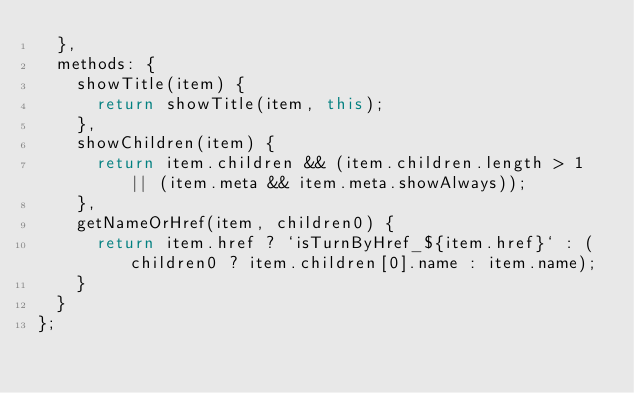Convert code to text. <code><loc_0><loc_0><loc_500><loc_500><_JavaScript_>  },
  methods: {
    showTitle(item) {
      return showTitle(item, this);
    },
    showChildren(item) {
      return item.children && (item.children.length > 1 || (item.meta && item.meta.showAlways));
    },
    getNameOrHref(item, children0) {
      return item.href ? `isTurnByHref_${item.href}` : (children0 ? item.children[0].name : item.name);
    }
  }
};
</code> 